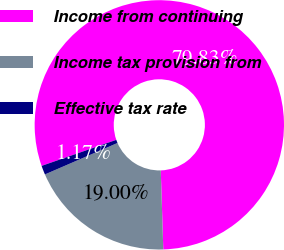<chart> <loc_0><loc_0><loc_500><loc_500><pie_chart><fcel>Income from continuing<fcel>Income tax provision from<fcel>Effective tax rate<nl><fcel>79.84%<fcel>19.0%<fcel>1.17%<nl></chart> 